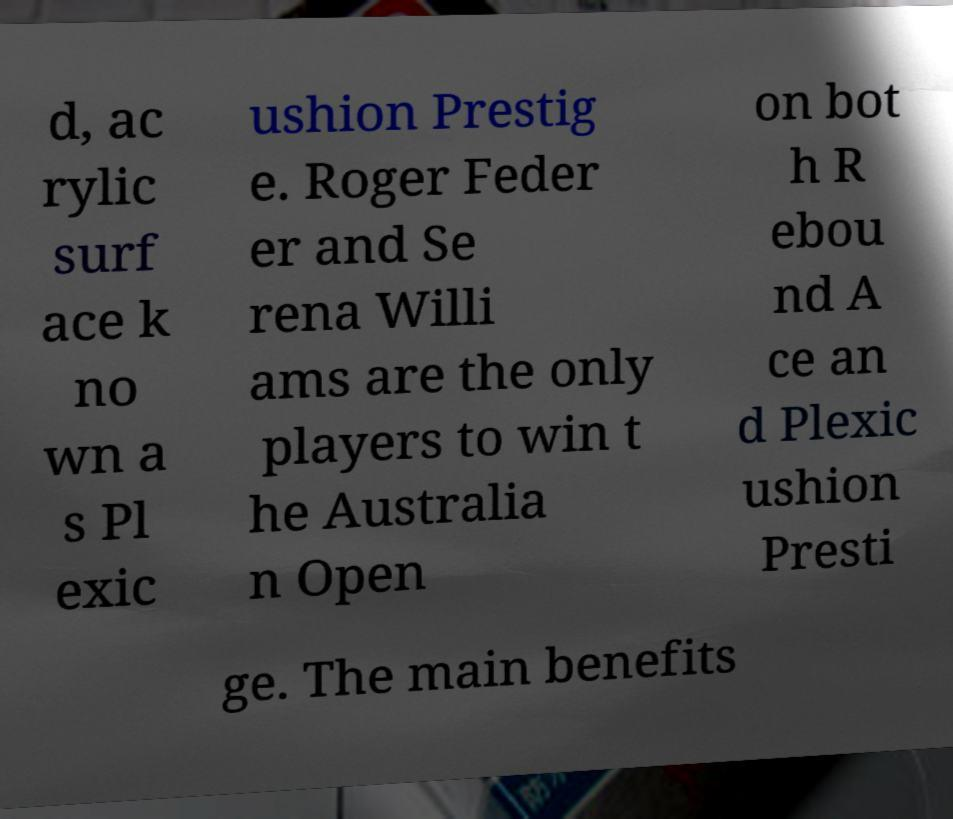There's text embedded in this image that I need extracted. Can you transcribe it verbatim? d, ac rylic surf ace k no wn a s Pl exic ushion Prestig e. Roger Feder er and Se rena Willi ams are the only players to win t he Australia n Open on bot h R ebou nd A ce an d Plexic ushion Presti ge. The main benefits 